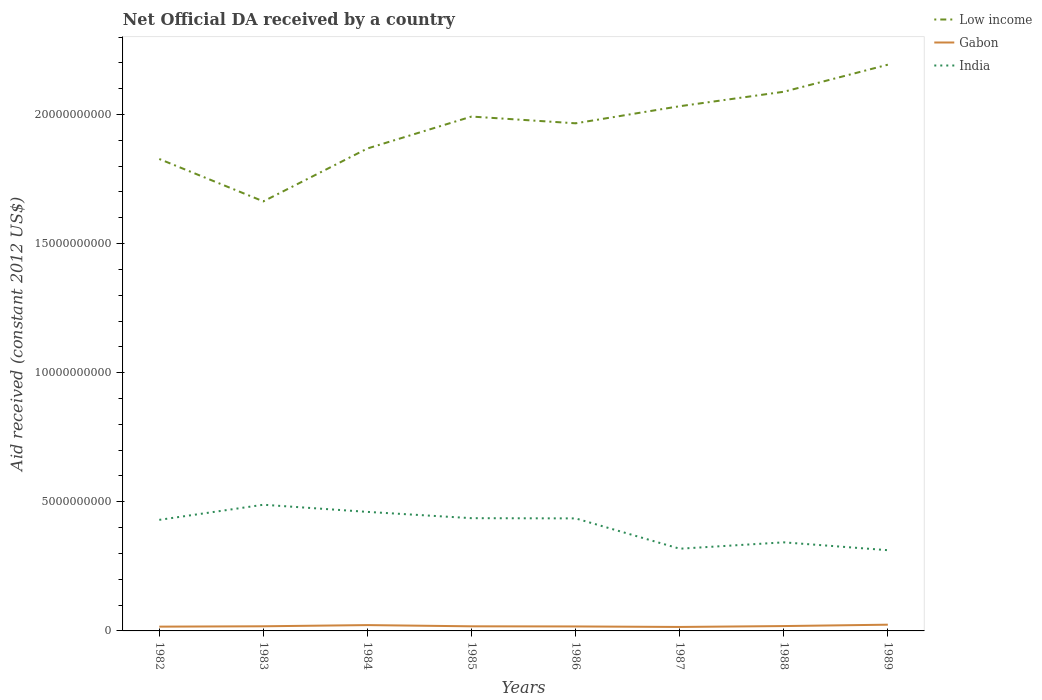How many different coloured lines are there?
Your answer should be compact. 3. Across all years, what is the maximum net official development assistance aid received in Low income?
Your response must be concise. 1.66e+1. In which year was the net official development assistance aid received in India maximum?
Offer a terse response. 1989. What is the total net official development assistance aid received in India in the graph?
Offer a very short reply. 1.18e+09. What is the difference between the highest and the second highest net official development assistance aid received in Gabon?
Ensure brevity in your answer.  8.77e+07. What is the difference between the highest and the lowest net official development assistance aid received in India?
Provide a short and direct response. 5. Does the graph contain any zero values?
Offer a terse response. No. How are the legend labels stacked?
Keep it short and to the point. Vertical. What is the title of the graph?
Offer a terse response. Net Official DA received by a country. What is the label or title of the X-axis?
Offer a terse response. Years. What is the label or title of the Y-axis?
Offer a terse response. Aid received (constant 2012 US$). What is the Aid received (constant 2012 US$) in Low income in 1982?
Offer a very short reply. 1.83e+1. What is the Aid received (constant 2012 US$) of Gabon in 1982?
Provide a succinct answer. 1.66e+08. What is the Aid received (constant 2012 US$) in India in 1982?
Ensure brevity in your answer.  4.30e+09. What is the Aid received (constant 2012 US$) of Low income in 1983?
Offer a very short reply. 1.66e+1. What is the Aid received (constant 2012 US$) in Gabon in 1983?
Your response must be concise. 1.80e+08. What is the Aid received (constant 2012 US$) of India in 1983?
Offer a very short reply. 4.89e+09. What is the Aid received (constant 2012 US$) of Low income in 1984?
Your answer should be compact. 1.87e+1. What is the Aid received (constant 2012 US$) in Gabon in 1984?
Your response must be concise. 2.26e+08. What is the Aid received (constant 2012 US$) of India in 1984?
Keep it short and to the point. 4.61e+09. What is the Aid received (constant 2012 US$) of Low income in 1985?
Your answer should be compact. 1.99e+1. What is the Aid received (constant 2012 US$) of Gabon in 1985?
Ensure brevity in your answer.  1.79e+08. What is the Aid received (constant 2012 US$) in India in 1985?
Your answer should be compact. 4.37e+09. What is the Aid received (constant 2012 US$) in Low income in 1986?
Give a very brief answer. 1.97e+1. What is the Aid received (constant 2012 US$) in Gabon in 1986?
Make the answer very short. 1.73e+08. What is the Aid received (constant 2012 US$) in India in 1986?
Give a very brief answer. 4.36e+09. What is the Aid received (constant 2012 US$) in Low income in 1987?
Provide a short and direct response. 2.03e+1. What is the Aid received (constant 2012 US$) of Gabon in 1987?
Offer a very short reply. 1.53e+08. What is the Aid received (constant 2012 US$) in India in 1987?
Keep it short and to the point. 3.18e+09. What is the Aid received (constant 2012 US$) in Low income in 1988?
Make the answer very short. 2.09e+1. What is the Aid received (constant 2012 US$) in Gabon in 1988?
Offer a terse response. 1.88e+08. What is the Aid received (constant 2012 US$) of India in 1988?
Provide a short and direct response. 3.43e+09. What is the Aid received (constant 2012 US$) of Low income in 1989?
Offer a terse response. 2.19e+1. What is the Aid received (constant 2012 US$) of Gabon in 1989?
Give a very brief answer. 2.41e+08. What is the Aid received (constant 2012 US$) of India in 1989?
Ensure brevity in your answer.  3.13e+09. Across all years, what is the maximum Aid received (constant 2012 US$) of Low income?
Your answer should be very brief. 2.19e+1. Across all years, what is the maximum Aid received (constant 2012 US$) in Gabon?
Provide a short and direct response. 2.41e+08. Across all years, what is the maximum Aid received (constant 2012 US$) in India?
Provide a succinct answer. 4.89e+09. Across all years, what is the minimum Aid received (constant 2012 US$) in Low income?
Your response must be concise. 1.66e+1. Across all years, what is the minimum Aid received (constant 2012 US$) of Gabon?
Offer a terse response. 1.53e+08. Across all years, what is the minimum Aid received (constant 2012 US$) of India?
Ensure brevity in your answer.  3.13e+09. What is the total Aid received (constant 2012 US$) in Low income in the graph?
Offer a terse response. 1.56e+11. What is the total Aid received (constant 2012 US$) of Gabon in the graph?
Ensure brevity in your answer.  1.51e+09. What is the total Aid received (constant 2012 US$) of India in the graph?
Your answer should be compact. 3.23e+1. What is the difference between the Aid received (constant 2012 US$) in Low income in 1982 and that in 1983?
Your response must be concise. 1.64e+09. What is the difference between the Aid received (constant 2012 US$) of Gabon in 1982 and that in 1983?
Your answer should be very brief. -1.36e+07. What is the difference between the Aid received (constant 2012 US$) of India in 1982 and that in 1983?
Provide a succinct answer. -5.85e+08. What is the difference between the Aid received (constant 2012 US$) in Low income in 1982 and that in 1984?
Offer a terse response. -4.07e+08. What is the difference between the Aid received (constant 2012 US$) of Gabon in 1982 and that in 1984?
Your answer should be compact. -5.96e+07. What is the difference between the Aid received (constant 2012 US$) of India in 1982 and that in 1984?
Make the answer very short. -3.08e+08. What is the difference between the Aid received (constant 2012 US$) of Low income in 1982 and that in 1985?
Provide a succinct answer. -1.64e+09. What is the difference between the Aid received (constant 2012 US$) of Gabon in 1982 and that in 1985?
Make the answer very short. -1.26e+07. What is the difference between the Aid received (constant 2012 US$) in India in 1982 and that in 1985?
Offer a very short reply. -6.47e+07. What is the difference between the Aid received (constant 2012 US$) of Low income in 1982 and that in 1986?
Ensure brevity in your answer.  -1.38e+09. What is the difference between the Aid received (constant 2012 US$) of Gabon in 1982 and that in 1986?
Give a very brief answer. -6.87e+06. What is the difference between the Aid received (constant 2012 US$) in India in 1982 and that in 1986?
Offer a terse response. -5.65e+07. What is the difference between the Aid received (constant 2012 US$) in Low income in 1982 and that in 1987?
Offer a terse response. -2.04e+09. What is the difference between the Aid received (constant 2012 US$) in Gabon in 1982 and that in 1987?
Ensure brevity in your answer.  1.25e+07. What is the difference between the Aid received (constant 2012 US$) of India in 1982 and that in 1987?
Make the answer very short. 1.12e+09. What is the difference between the Aid received (constant 2012 US$) in Low income in 1982 and that in 1988?
Ensure brevity in your answer.  -2.60e+09. What is the difference between the Aid received (constant 2012 US$) of Gabon in 1982 and that in 1988?
Give a very brief answer. -2.25e+07. What is the difference between the Aid received (constant 2012 US$) in India in 1982 and that in 1988?
Keep it short and to the point. 8.71e+08. What is the difference between the Aid received (constant 2012 US$) in Low income in 1982 and that in 1989?
Give a very brief answer. -3.65e+09. What is the difference between the Aid received (constant 2012 US$) of Gabon in 1982 and that in 1989?
Offer a terse response. -7.52e+07. What is the difference between the Aid received (constant 2012 US$) of India in 1982 and that in 1989?
Make the answer very short. 1.18e+09. What is the difference between the Aid received (constant 2012 US$) of Low income in 1983 and that in 1984?
Provide a succinct answer. -2.05e+09. What is the difference between the Aid received (constant 2012 US$) in Gabon in 1983 and that in 1984?
Keep it short and to the point. -4.60e+07. What is the difference between the Aid received (constant 2012 US$) of India in 1983 and that in 1984?
Keep it short and to the point. 2.77e+08. What is the difference between the Aid received (constant 2012 US$) of Low income in 1983 and that in 1985?
Ensure brevity in your answer.  -3.28e+09. What is the difference between the Aid received (constant 2012 US$) in Gabon in 1983 and that in 1985?
Your response must be concise. 1.05e+06. What is the difference between the Aid received (constant 2012 US$) of India in 1983 and that in 1985?
Provide a succinct answer. 5.20e+08. What is the difference between the Aid received (constant 2012 US$) of Low income in 1983 and that in 1986?
Offer a terse response. -3.02e+09. What is the difference between the Aid received (constant 2012 US$) of Gabon in 1983 and that in 1986?
Give a very brief answer. 6.77e+06. What is the difference between the Aid received (constant 2012 US$) of India in 1983 and that in 1986?
Provide a short and direct response. 5.29e+08. What is the difference between the Aid received (constant 2012 US$) in Low income in 1983 and that in 1987?
Your response must be concise. -3.69e+09. What is the difference between the Aid received (constant 2012 US$) of Gabon in 1983 and that in 1987?
Provide a short and direct response. 2.61e+07. What is the difference between the Aid received (constant 2012 US$) in India in 1983 and that in 1987?
Offer a terse response. 1.70e+09. What is the difference between the Aid received (constant 2012 US$) of Low income in 1983 and that in 1988?
Make the answer very short. -4.25e+09. What is the difference between the Aid received (constant 2012 US$) of Gabon in 1983 and that in 1988?
Your answer should be compact. -8.87e+06. What is the difference between the Aid received (constant 2012 US$) in India in 1983 and that in 1988?
Give a very brief answer. 1.46e+09. What is the difference between the Aid received (constant 2012 US$) of Low income in 1983 and that in 1989?
Provide a short and direct response. -5.29e+09. What is the difference between the Aid received (constant 2012 US$) in Gabon in 1983 and that in 1989?
Give a very brief answer. -6.16e+07. What is the difference between the Aid received (constant 2012 US$) of India in 1983 and that in 1989?
Your answer should be very brief. 1.76e+09. What is the difference between the Aid received (constant 2012 US$) of Low income in 1984 and that in 1985?
Your response must be concise. -1.24e+09. What is the difference between the Aid received (constant 2012 US$) in Gabon in 1984 and that in 1985?
Your response must be concise. 4.70e+07. What is the difference between the Aid received (constant 2012 US$) of India in 1984 and that in 1985?
Your answer should be very brief. 2.44e+08. What is the difference between the Aid received (constant 2012 US$) in Low income in 1984 and that in 1986?
Offer a terse response. -9.75e+08. What is the difference between the Aid received (constant 2012 US$) of Gabon in 1984 and that in 1986?
Provide a short and direct response. 5.27e+07. What is the difference between the Aid received (constant 2012 US$) of India in 1984 and that in 1986?
Keep it short and to the point. 2.52e+08. What is the difference between the Aid received (constant 2012 US$) of Low income in 1984 and that in 1987?
Your response must be concise. -1.64e+09. What is the difference between the Aid received (constant 2012 US$) in Gabon in 1984 and that in 1987?
Your answer should be compact. 7.21e+07. What is the difference between the Aid received (constant 2012 US$) in India in 1984 and that in 1987?
Provide a short and direct response. 1.43e+09. What is the difference between the Aid received (constant 2012 US$) of Low income in 1984 and that in 1988?
Provide a short and direct response. -2.20e+09. What is the difference between the Aid received (constant 2012 US$) in Gabon in 1984 and that in 1988?
Your answer should be very brief. 3.71e+07. What is the difference between the Aid received (constant 2012 US$) in India in 1984 and that in 1988?
Keep it short and to the point. 1.18e+09. What is the difference between the Aid received (constant 2012 US$) of Low income in 1984 and that in 1989?
Ensure brevity in your answer.  -3.25e+09. What is the difference between the Aid received (constant 2012 US$) of Gabon in 1984 and that in 1989?
Offer a terse response. -1.56e+07. What is the difference between the Aid received (constant 2012 US$) in India in 1984 and that in 1989?
Provide a succinct answer. 1.48e+09. What is the difference between the Aid received (constant 2012 US$) of Low income in 1985 and that in 1986?
Offer a terse response. 2.61e+08. What is the difference between the Aid received (constant 2012 US$) in Gabon in 1985 and that in 1986?
Keep it short and to the point. 5.72e+06. What is the difference between the Aid received (constant 2012 US$) in India in 1985 and that in 1986?
Ensure brevity in your answer.  8.18e+06. What is the difference between the Aid received (constant 2012 US$) of Low income in 1985 and that in 1987?
Provide a short and direct response. -4.01e+08. What is the difference between the Aid received (constant 2012 US$) of Gabon in 1985 and that in 1987?
Give a very brief answer. 2.51e+07. What is the difference between the Aid received (constant 2012 US$) of India in 1985 and that in 1987?
Provide a short and direct response. 1.18e+09. What is the difference between the Aid received (constant 2012 US$) in Low income in 1985 and that in 1988?
Your response must be concise. -9.61e+08. What is the difference between the Aid received (constant 2012 US$) in Gabon in 1985 and that in 1988?
Your answer should be very brief. -9.92e+06. What is the difference between the Aid received (constant 2012 US$) of India in 1985 and that in 1988?
Your answer should be compact. 9.36e+08. What is the difference between the Aid received (constant 2012 US$) in Low income in 1985 and that in 1989?
Give a very brief answer. -2.01e+09. What is the difference between the Aid received (constant 2012 US$) in Gabon in 1985 and that in 1989?
Your answer should be compact. -6.26e+07. What is the difference between the Aid received (constant 2012 US$) in India in 1985 and that in 1989?
Provide a short and direct response. 1.24e+09. What is the difference between the Aid received (constant 2012 US$) in Low income in 1986 and that in 1987?
Your response must be concise. -6.62e+08. What is the difference between the Aid received (constant 2012 US$) of Gabon in 1986 and that in 1987?
Offer a very short reply. 1.93e+07. What is the difference between the Aid received (constant 2012 US$) of India in 1986 and that in 1987?
Your answer should be very brief. 1.17e+09. What is the difference between the Aid received (constant 2012 US$) in Low income in 1986 and that in 1988?
Make the answer very short. -1.22e+09. What is the difference between the Aid received (constant 2012 US$) in Gabon in 1986 and that in 1988?
Make the answer very short. -1.56e+07. What is the difference between the Aid received (constant 2012 US$) of India in 1986 and that in 1988?
Keep it short and to the point. 9.27e+08. What is the difference between the Aid received (constant 2012 US$) of Low income in 1986 and that in 1989?
Make the answer very short. -2.27e+09. What is the difference between the Aid received (constant 2012 US$) in Gabon in 1986 and that in 1989?
Your answer should be very brief. -6.83e+07. What is the difference between the Aid received (constant 2012 US$) in India in 1986 and that in 1989?
Make the answer very short. 1.23e+09. What is the difference between the Aid received (constant 2012 US$) in Low income in 1987 and that in 1988?
Keep it short and to the point. -5.61e+08. What is the difference between the Aid received (constant 2012 US$) in Gabon in 1987 and that in 1988?
Keep it short and to the point. -3.50e+07. What is the difference between the Aid received (constant 2012 US$) in India in 1987 and that in 1988?
Ensure brevity in your answer.  -2.47e+08. What is the difference between the Aid received (constant 2012 US$) of Low income in 1987 and that in 1989?
Your response must be concise. -1.61e+09. What is the difference between the Aid received (constant 2012 US$) of Gabon in 1987 and that in 1989?
Your answer should be compact. -8.77e+07. What is the difference between the Aid received (constant 2012 US$) in India in 1987 and that in 1989?
Offer a terse response. 5.72e+07. What is the difference between the Aid received (constant 2012 US$) of Low income in 1988 and that in 1989?
Your response must be concise. -1.05e+09. What is the difference between the Aid received (constant 2012 US$) of Gabon in 1988 and that in 1989?
Give a very brief answer. -5.27e+07. What is the difference between the Aid received (constant 2012 US$) of India in 1988 and that in 1989?
Keep it short and to the point. 3.04e+08. What is the difference between the Aid received (constant 2012 US$) in Low income in 1982 and the Aid received (constant 2012 US$) in Gabon in 1983?
Ensure brevity in your answer.  1.81e+1. What is the difference between the Aid received (constant 2012 US$) in Low income in 1982 and the Aid received (constant 2012 US$) in India in 1983?
Provide a short and direct response. 1.34e+1. What is the difference between the Aid received (constant 2012 US$) in Gabon in 1982 and the Aid received (constant 2012 US$) in India in 1983?
Give a very brief answer. -4.72e+09. What is the difference between the Aid received (constant 2012 US$) in Low income in 1982 and the Aid received (constant 2012 US$) in Gabon in 1984?
Offer a very short reply. 1.81e+1. What is the difference between the Aid received (constant 2012 US$) in Low income in 1982 and the Aid received (constant 2012 US$) in India in 1984?
Your response must be concise. 1.37e+1. What is the difference between the Aid received (constant 2012 US$) in Gabon in 1982 and the Aid received (constant 2012 US$) in India in 1984?
Your answer should be compact. -4.44e+09. What is the difference between the Aid received (constant 2012 US$) in Low income in 1982 and the Aid received (constant 2012 US$) in Gabon in 1985?
Make the answer very short. 1.81e+1. What is the difference between the Aid received (constant 2012 US$) in Low income in 1982 and the Aid received (constant 2012 US$) in India in 1985?
Make the answer very short. 1.39e+1. What is the difference between the Aid received (constant 2012 US$) in Gabon in 1982 and the Aid received (constant 2012 US$) in India in 1985?
Keep it short and to the point. -4.20e+09. What is the difference between the Aid received (constant 2012 US$) of Low income in 1982 and the Aid received (constant 2012 US$) of Gabon in 1986?
Ensure brevity in your answer.  1.81e+1. What is the difference between the Aid received (constant 2012 US$) of Low income in 1982 and the Aid received (constant 2012 US$) of India in 1986?
Your response must be concise. 1.39e+1. What is the difference between the Aid received (constant 2012 US$) of Gabon in 1982 and the Aid received (constant 2012 US$) of India in 1986?
Your answer should be compact. -4.19e+09. What is the difference between the Aid received (constant 2012 US$) of Low income in 1982 and the Aid received (constant 2012 US$) of Gabon in 1987?
Make the answer very short. 1.81e+1. What is the difference between the Aid received (constant 2012 US$) in Low income in 1982 and the Aid received (constant 2012 US$) in India in 1987?
Keep it short and to the point. 1.51e+1. What is the difference between the Aid received (constant 2012 US$) of Gabon in 1982 and the Aid received (constant 2012 US$) of India in 1987?
Your answer should be very brief. -3.02e+09. What is the difference between the Aid received (constant 2012 US$) of Low income in 1982 and the Aid received (constant 2012 US$) of Gabon in 1988?
Make the answer very short. 1.81e+1. What is the difference between the Aid received (constant 2012 US$) in Low income in 1982 and the Aid received (constant 2012 US$) in India in 1988?
Your response must be concise. 1.48e+1. What is the difference between the Aid received (constant 2012 US$) of Gabon in 1982 and the Aid received (constant 2012 US$) of India in 1988?
Your answer should be compact. -3.26e+09. What is the difference between the Aid received (constant 2012 US$) in Low income in 1982 and the Aid received (constant 2012 US$) in Gabon in 1989?
Offer a very short reply. 1.80e+1. What is the difference between the Aid received (constant 2012 US$) in Low income in 1982 and the Aid received (constant 2012 US$) in India in 1989?
Ensure brevity in your answer.  1.52e+1. What is the difference between the Aid received (constant 2012 US$) of Gabon in 1982 and the Aid received (constant 2012 US$) of India in 1989?
Give a very brief answer. -2.96e+09. What is the difference between the Aid received (constant 2012 US$) in Low income in 1983 and the Aid received (constant 2012 US$) in Gabon in 1984?
Your answer should be compact. 1.64e+1. What is the difference between the Aid received (constant 2012 US$) of Low income in 1983 and the Aid received (constant 2012 US$) of India in 1984?
Keep it short and to the point. 1.20e+1. What is the difference between the Aid received (constant 2012 US$) in Gabon in 1983 and the Aid received (constant 2012 US$) in India in 1984?
Ensure brevity in your answer.  -4.43e+09. What is the difference between the Aid received (constant 2012 US$) in Low income in 1983 and the Aid received (constant 2012 US$) in Gabon in 1985?
Keep it short and to the point. 1.65e+1. What is the difference between the Aid received (constant 2012 US$) of Low income in 1983 and the Aid received (constant 2012 US$) of India in 1985?
Give a very brief answer. 1.23e+1. What is the difference between the Aid received (constant 2012 US$) of Gabon in 1983 and the Aid received (constant 2012 US$) of India in 1985?
Provide a succinct answer. -4.19e+09. What is the difference between the Aid received (constant 2012 US$) in Low income in 1983 and the Aid received (constant 2012 US$) in Gabon in 1986?
Provide a succinct answer. 1.65e+1. What is the difference between the Aid received (constant 2012 US$) of Low income in 1983 and the Aid received (constant 2012 US$) of India in 1986?
Make the answer very short. 1.23e+1. What is the difference between the Aid received (constant 2012 US$) of Gabon in 1983 and the Aid received (constant 2012 US$) of India in 1986?
Provide a short and direct response. -4.18e+09. What is the difference between the Aid received (constant 2012 US$) of Low income in 1983 and the Aid received (constant 2012 US$) of Gabon in 1987?
Your answer should be very brief. 1.65e+1. What is the difference between the Aid received (constant 2012 US$) of Low income in 1983 and the Aid received (constant 2012 US$) of India in 1987?
Provide a short and direct response. 1.35e+1. What is the difference between the Aid received (constant 2012 US$) of Gabon in 1983 and the Aid received (constant 2012 US$) of India in 1987?
Make the answer very short. -3.00e+09. What is the difference between the Aid received (constant 2012 US$) in Low income in 1983 and the Aid received (constant 2012 US$) in Gabon in 1988?
Your answer should be very brief. 1.64e+1. What is the difference between the Aid received (constant 2012 US$) of Low income in 1983 and the Aid received (constant 2012 US$) of India in 1988?
Your answer should be compact. 1.32e+1. What is the difference between the Aid received (constant 2012 US$) in Gabon in 1983 and the Aid received (constant 2012 US$) in India in 1988?
Provide a short and direct response. -3.25e+09. What is the difference between the Aid received (constant 2012 US$) of Low income in 1983 and the Aid received (constant 2012 US$) of Gabon in 1989?
Your answer should be very brief. 1.64e+1. What is the difference between the Aid received (constant 2012 US$) of Low income in 1983 and the Aid received (constant 2012 US$) of India in 1989?
Your answer should be very brief. 1.35e+1. What is the difference between the Aid received (constant 2012 US$) of Gabon in 1983 and the Aid received (constant 2012 US$) of India in 1989?
Offer a very short reply. -2.95e+09. What is the difference between the Aid received (constant 2012 US$) in Low income in 1984 and the Aid received (constant 2012 US$) in Gabon in 1985?
Offer a terse response. 1.85e+1. What is the difference between the Aid received (constant 2012 US$) of Low income in 1984 and the Aid received (constant 2012 US$) of India in 1985?
Your response must be concise. 1.43e+1. What is the difference between the Aid received (constant 2012 US$) in Gabon in 1984 and the Aid received (constant 2012 US$) in India in 1985?
Give a very brief answer. -4.14e+09. What is the difference between the Aid received (constant 2012 US$) of Low income in 1984 and the Aid received (constant 2012 US$) of Gabon in 1986?
Your answer should be compact. 1.85e+1. What is the difference between the Aid received (constant 2012 US$) of Low income in 1984 and the Aid received (constant 2012 US$) of India in 1986?
Make the answer very short. 1.43e+1. What is the difference between the Aid received (constant 2012 US$) of Gabon in 1984 and the Aid received (constant 2012 US$) of India in 1986?
Offer a very short reply. -4.13e+09. What is the difference between the Aid received (constant 2012 US$) of Low income in 1984 and the Aid received (constant 2012 US$) of Gabon in 1987?
Make the answer very short. 1.85e+1. What is the difference between the Aid received (constant 2012 US$) in Low income in 1984 and the Aid received (constant 2012 US$) in India in 1987?
Keep it short and to the point. 1.55e+1. What is the difference between the Aid received (constant 2012 US$) of Gabon in 1984 and the Aid received (constant 2012 US$) of India in 1987?
Offer a very short reply. -2.96e+09. What is the difference between the Aid received (constant 2012 US$) of Low income in 1984 and the Aid received (constant 2012 US$) of Gabon in 1988?
Your answer should be very brief. 1.85e+1. What is the difference between the Aid received (constant 2012 US$) of Low income in 1984 and the Aid received (constant 2012 US$) of India in 1988?
Your response must be concise. 1.53e+1. What is the difference between the Aid received (constant 2012 US$) in Gabon in 1984 and the Aid received (constant 2012 US$) in India in 1988?
Offer a terse response. -3.21e+09. What is the difference between the Aid received (constant 2012 US$) of Low income in 1984 and the Aid received (constant 2012 US$) of Gabon in 1989?
Ensure brevity in your answer.  1.84e+1. What is the difference between the Aid received (constant 2012 US$) in Low income in 1984 and the Aid received (constant 2012 US$) in India in 1989?
Give a very brief answer. 1.56e+1. What is the difference between the Aid received (constant 2012 US$) in Gabon in 1984 and the Aid received (constant 2012 US$) in India in 1989?
Keep it short and to the point. -2.90e+09. What is the difference between the Aid received (constant 2012 US$) in Low income in 1985 and the Aid received (constant 2012 US$) in Gabon in 1986?
Provide a short and direct response. 1.97e+1. What is the difference between the Aid received (constant 2012 US$) in Low income in 1985 and the Aid received (constant 2012 US$) in India in 1986?
Keep it short and to the point. 1.56e+1. What is the difference between the Aid received (constant 2012 US$) of Gabon in 1985 and the Aid received (constant 2012 US$) of India in 1986?
Offer a terse response. -4.18e+09. What is the difference between the Aid received (constant 2012 US$) of Low income in 1985 and the Aid received (constant 2012 US$) of Gabon in 1987?
Provide a succinct answer. 1.98e+1. What is the difference between the Aid received (constant 2012 US$) of Low income in 1985 and the Aid received (constant 2012 US$) of India in 1987?
Your response must be concise. 1.67e+1. What is the difference between the Aid received (constant 2012 US$) in Gabon in 1985 and the Aid received (constant 2012 US$) in India in 1987?
Your response must be concise. -3.01e+09. What is the difference between the Aid received (constant 2012 US$) of Low income in 1985 and the Aid received (constant 2012 US$) of Gabon in 1988?
Provide a short and direct response. 1.97e+1. What is the difference between the Aid received (constant 2012 US$) of Low income in 1985 and the Aid received (constant 2012 US$) of India in 1988?
Ensure brevity in your answer.  1.65e+1. What is the difference between the Aid received (constant 2012 US$) in Gabon in 1985 and the Aid received (constant 2012 US$) in India in 1988?
Your answer should be compact. -3.25e+09. What is the difference between the Aid received (constant 2012 US$) of Low income in 1985 and the Aid received (constant 2012 US$) of Gabon in 1989?
Provide a succinct answer. 1.97e+1. What is the difference between the Aid received (constant 2012 US$) of Low income in 1985 and the Aid received (constant 2012 US$) of India in 1989?
Your response must be concise. 1.68e+1. What is the difference between the Aid received (constant 2012 US$) of Gabon in 1985 and the Aid received (constant 2012 US$) of India in 1989?
Ensure brevity in your answer.  -2.95e+09. What is the difference between the Aid received (constant 2012 US$) of Low income in 1986 and the Aid received (constant 2012 US$) of Gabon in 1987?
Offer a terse response. 1.95e+1. What is the difference between the Aid received (constant 2012 US$) of Low income in 1986 and the Aid received (constant 2012 US$) of India in 1987?
Provide a succinct answer. 1.65e+1. What is the difference between the Aid received (constant 2012 US$) in Gabon in 1986 and the Aid received (constant 2012 US$) in India in 1987?
Give a very brief answer. -3.01e+09. What is the difference between the Aid received (constant 2012 US$) in Low income in 1986 and the Aid received (constant 2012 US$) in Gabon in 1988?
Give a very brief answer. 1.95e+1. What is the difference between the Aid received (constant 2012 US$) in Low income in 1986 and the Aid received (constant 2012 US$) in India in 1988?
Your answer should be compact. 1.62e+1. What is the difference between the Aid received (constant 2012 US$) of Gabon in 1986 and the Aid received (constant 2012 US$) of India in 1988?
Your response must be concise. -3.26e+09. What is the difference between the Aid received (constant 2012 US$) of Low income in 1986 and the Aid received (constant 2012 US$) of Gabon in 1989?
Offer a very short reply. 1.94e+1. What is the difference between the Aid received (constant 2012 US$) of Low income in 1986 and the Aid received (constant 2012 US$) of India in 1989?
Your answer should be compact. 1.65e+1. What is the difference between the Aid received (constant 2012 US$) of Gabon in 1986 and the Aid received (constant 2012 US$) of India in 1989?
Make the answer very short. -2.95e+09. What is the difference between the Aid received (constant 2012 US$) in Low income in 1987 and the Aid received (constant 2012 US$) in Gabon in 1988?
Offer a very short reply. 2.01e+1. What is the difference between the Aid received (constant 2012 US$) in Low income in 1987 and the Aid received (constant 2012 US$) in India in 1988?
Ensure brevity in your answer.  1.69e+1. What is the difference between the Aid received (constant 2012 US$) of Gabon in 1987 and the Aid received (constant 2012 US$) of India in 1988?
Provide a succinct answer. -3.28e+09. What is the difference between the Aid received (constant 2012 US$) of Low income in 1987 and the Aid received (constant 2012 US$) of Gabon in 1989?
Your answer should be compact. 2.01e+1. What is the difference between the Aid received (constant 2012 US$) of Low income in 1987 and the Aid received (constant 2012 US$) of India in 1989?
Your answer should be very brief. 1.72e+1. What is the difference between the Aid received (constant 2012 US$) of Gabon in 1987 and the Aid received (constant 2012 US$) of India in 1989?
Provide a succinct answer. -2.97e+09. What is the difference between the Aid received (constant 2012 US$) of Low income in 1988 and the Aid received (constant 2012 US$) of Gabon in 1989?
Give a very brief answer. 2.06e+1. What is the difference between the Aid received (constant 2012 US$) of Low income in 1988 and the Aid received (constant 2012 US$) of India in 1989?
Offer a very short reply. 1.78e+1. What is the difference between the Aid received (constant 2012 US$) of Gabon in 1988 and the Aid received (constant 2012 US$) of India in 1989?
Your response must be concise. -2.94e+09. What is the average Aid received (constant 2012 US$) of Low income per year?
Give a very brief answer. 1.95e+1. What is the average Aid received (constant 2012 US$) in Gabon per year?
Keep it short and to the point. 1.88e+08. What is the average Aid received (constant 2012 US$) of India per year?
Offer a very short reply. 4.03e+09. In the year 1982, what is the difference between the Aid received (constant 2012 US$) of Low income and Aid received (constant 2012 US$) of Gabon?
Offer a very short reply. 1.81e+1. In the year 1982, what is the difference between the Aid received (constant 2012 US$) of Low income and Aid received (constant 2012 US$) of India?
Make the answer very short. 1.40e+1. In the year 1982, what is the difference between the Aid received (constant 2012 US$) of Gabon and Aid received (constant 2012 US$) of India?
Give a very brief answer. -4.14e+09. In the year 1983, what is the difference between the Aid received (constant 2012 US$) in Low income and Aid received (constant 2012 US$) in Gabon?
Ensure brevity in your answer.  1.65e+1. In the year 1983, what is the difference between the Aid received (constant 2012 US$) in Low income and Aid received (constant 2012 US$) in India?
Your answer should be very brief. 1.17e+1. In the year 1983, what is the difference between the Aid received (constant 2012 US$) of Gabon and Aid received (constant 2012 US$) of India?
Your answer should be very brief. -4.71e+09. In the year 1984, what is the difference between the Aid received (constant 2012 US$) of Low income and Aid received (constant 2012 US$) of Gabon?
Provide a succinct answer. 1.85e+1. In the year 1984, what is the difference between the Aid received (constant 2012 US$) of Low income and Aid received (constant 2012 US$) of India?
Offer a very short reply. 1.41e+1. In the year 1984, what is the difference between the Aid received (constant 2012 US$) in Gabon and Aid received (constant 2012 US$) in India?
Provide a short and direct response. -4.38e+09. In the year 1985, what is the difference between the Aid received (constant 2012 US$) of Low income and Aid received (constant 2012 US$) of Gabon?
Provide a succinct answer. 1.97e+1. In the year 1985, what is the difference between the Aid received (constant 2012 US$) of Low income and Aid received (constant 2012 US$) of India?
Your answer should be very brief. 1.56e+1. In the year 1985, what is the difference between the Aid received (constant 2012 US$) in Gabon and Aid received (constant 2012 US$) in India?
Offer a terse response. -4.19e+09. In the year 1986, what is the difference between the Aid received (constant 2012 US$) of Low income and Aid received (constant 2012 US$) of Gabon?
Your answer should be very brief. 1.95e+1. In the year 1986, what is the difference between the Aid received (constant 2012 US$) in Low income and Aid received (constant 2012 US$) in India?
Provide a short and direct response. 1.53e+1. In the year 1986, what is the difference between the Aid received (constant 2012 US$) in Gabon and Aid received (constant 2012 US$) in India?
Your response must be concise. -4.19e+09. In the year 1987, what is the difference between the Aid received (constant 2012 US$) in Low income and Aid received (constant 2012 US$) in Gabon?
Provide a short and direct response. 2.02e+1. In the year 1987, what is the difference between the Aid received (constant 2012 US$) in Low income and Aid received (constant 2012 US$) in India?
Provide a short and direct response. 1.71e+1. In the year 1987, what is the difference between the Aid received (constant 2012 US$) in Gabon and Aid received (constant 2012 US$) in India?
Your response must be concise. -3.03e+09. In the year 1988, what is the difference between the Aid received (constant 2012 US$) in Low income and Aid received (constant 2012 US$) in Gabon?
Your response must be concise. 2.07e+1. In the year 1988, what is the difference between the Aid received (constant 2012 US$) in Low income and Aid received (constant 2012 US$) in India?
Give a very brief answer. 1.75e+1. In the year 1988, what is the difference between the Aid received (constant 2012 US$) in Gabon and Aid received (constant 2012 US$) in India?
Provide a short and direct response. -3.24e+09. In the year 1989, what is the difference between the Aid received (constant 2012 US$) in Low income and Aid received (constant 2012 US$) in Gabon?
Make the answer very short. 2.17e+1. In the year 1989, what is the difference between the Aid received (constant 2012 US$) of Low income and Aid received (constant 2012 US$) of India?
Ensure brevity in your answer.  1.88e+1. In the year 1989, what is the difference between the Aid received (constant 2012 US$) of Gabon and Aid received (constant 2012 US$) of India?
Ensure brevity in your answer.  -2.89e+09. What is the ratio of the Aid received (constant 2012 US$) of Low income in 1982 to that in 1983?
Keep it short and to the point. 1.1. What is the ratio of the Aid received (constant 2012 US$) in Gabon in 1982 to that in 1983?
Keep it short and to the point. 0.92. What is the ratio of the Aid received (constant 2012 US$) in India in 1982 to that in 1983?
Your answer should be very brief. 0.88. What is the ratio of the Aid received (constant 2012 US$) of Low income in 1982 to that in 1984?
Provide a short and direct response. 0.98. What is the ratio of the Aid received (constant 2012 US$) of Gabon in 1982 to that in 1984?
Your answer should be very brief. 0.74. What is the ratio of the Aid received (constant 2012 US$) in India in 1982 to that in 1984?
Give a very brief answer. 0.93. What is the ratio of the Aid received (constant 2012 US$) in Low income in 1982 to that in 1985?
Keep it short and to the point. 0.92. What is the ratio of the Aid received (constant 2012 US$) of Gabon in 1982 to that in 1985?
Offer a very short reply. 0.93. What is the ratio of the Aid received (constant 2012 US$) in India in 1982 to that in 1985?
Provide a short and direct response. 0.99. What is the ratio of the Aid received (constant 2012 US$) of Low income in 1982 to that in 1986?
Give a very brief answer. 0.93. What is the ratio of the Aid received (constant 2012 US$) of Gabon in 1982 to that in 1986?
Give a very brief answer. 0.96. What is the ratio of the Aid received (constant 2012 US$) of India in 1982 to that in 1986?
Keep it short and to the point. 0.99. What is the ratio of the Aid received (constant 2012 US$) of Low income in 1982 to that in 1987?
Offer a terse response. 0.9. What is the ratio of the Aid received (constant 2012 US$) of Gabon in 1982 to that in 1987?
Make the answer very short. 1.08. What is the ratio of the Aid received (constant 2012 US$) in India in 1982 to that in 1987?
Your answer should be compact. 1.35. What is the ratio of the Aid received (constant 2012 US$) of Low income in 1982 to that in 1988?
Offer a very short reply. 0.88. What is the ratio of the Aid received (constant 2012 US$) of Gabon in 1982 to that in 1988?
Your answer should be compact. 0.88. What is the ratio of the Aid received (constant 2012 US$) in India in 1982 to that in 1988?
Provide a succinct answer. 1.25. What is the ratio of the Aid received (constant 2012 US$) in Low income in 1982 to that in 1989?
Ensure brevity in your answer.  0.83. What is the ratio of the Aid received (constant 2012 US$) in Gabon in 1982 to that in 1989?
Offer a terse response. 0.69. What is the ratio of the Aid received (constant 2012 US$) in India in 1982 to that in 1989?
Your answer should be very brief. 1.38. What is the ratio of the Aid received (constant 2012 US$) of Low income in 1983 to that in 1984?
Your answer should be very brief. 0.89. What is the ratio of the Aid received (constant 2012 US$) of Gabon in 1983 to that in 1984?
Give a very brief answer. 0.8. What is the ratio of the Aid received (constant 2012 US$) in India in 1983 to that in 1984?
Provide a succinct answer. 1.06. What is the ratio of the Aid received (constant 2012 US$) of Low income in 1983 to that in 1985?
Ensure brevity in your answer.  0.84. What is the ratio of the Aid received (constant 2012 US$) of Gabon in 1983 to that in 1985?
Keep it short and to the point. 1.01. What is the ratio of the Aid received (constant 2012 US$) in India in 1983 to that in 1985?
Your response must be concise. 1.12. What is the ratio of the Aid received (constant 2012 US$) of Low income in 1983 to that in 1986?
Your response must be concise. 0.85. What is the ratio of the Aid received (constant 2012 US$) of Gabon in 1983 to that in 1986?
Your answer should be very brief. 1.04. What is the ratio of the Aid received (constant 2012 US$) of India in 1983 to that in 1986?
Offer a very short reply. 1.12. What is the ratio of the Aid received (constant 2012 US$) in Low income in 1983 to that in 1987?
Make the answer very short. 0.82. What is the ratio of the Aid received (constant 2012 US$) in Gabon in 1983 to that in 1987?
Make the answer very short. 1.17. What is the ratio of the Aid received (constant 2012 US$) in India in 1983 to that in 1987?
Offer a terse response. 1.53. What is the ratio of the Aid received (constant 2012 US$) of Low income in 1983 to that in 1988?
Ensure brevity in your answer.  0.8. What is the ratio of the Aid received (constant 2012 US$) in Gabon in 1983 to that in 1988?
Offer a terse response. 0.95. What is the ratio of the Aid received (constant 2012 US$) in India in 1983 to that in 1988?
Offer a very short reply. 1.42. What is the ratio of the Aid received (constant 2012 US$) of Low income in 1983 to that in 1989?
Your response must be concise. 0.76. What is the ratio of the Aid received (constant 2012 US$) of Gabon in 1983 to that in 1989?
Give a very brief answer. 0.74. What is the ratio of the Aid received (constant 2012 US$) in India in 1983 to that in 1989?
Keep it short and to the point. 1.56. What is the ratio of the Aid received (constant 2012 US$) in Low income in 1984 to that in 1985?
Keep it short and to the point. 0.94. What is the ratio of the Aid received (constant 2012 US$) of Gabon in 1984 to that in 1985?
Make the answer very short. 1.26. What is the ratio of the Aid received (constant 2012 US$) in India in 1984 to that in 1985?
Ensure brevity in your answer.  1.06. What is the ratio of the Aid received (constant 2012 US$) of Low income in 1984 to that in 1986?
Make the answer very short. 0.95. What is the ratio of the Aid received (constant 2012 US$) of Gabon in 1984 to that in 1986?
Your response must be concise. 1.31. What is the ratio of the Aid received (constant 2012 US$) of India in 1984 to that in 1986?
Provide a short and direct response. 1.06. What is the ratio of the Aid received (constant 2012 US$) in Low income in 1984 to that in 1987?
Provide a short and direct response. 0.92. What is the ratio of the Aid received (constant 2012 US$) in Gabon in 1984 to that in 1987?
Give a very brief answer. 1.47. What is the ratio of the Aid received (constant 2012 US$) in India in 1984 to that in 1987?
Your response must be concise. 1.45. What is the ratio of the Aid received (constant 2012 US$) of Low income in 1984 to that in 1988?
Your response must be concise. 0.89. What is the ratio of the Aid received (constant 2012 US$) of Gabon in 1984 to that in 1988?
Your response must be concise. 1.2. What is the ratio of the Aid received (constant 2012 US$) in India in 1984 to that in 1988?
Provide a short and direct response. 1.34. What is the ratio of the Aid received (constant 2012 US$) in Low income in 1984 to that in 1989?
Offer a terse response. 0.85. What is the ratio of the Aid received (constant 2012 US$) of Gabon in 1984 to that in 1989?
Offer a terse response. 0.94. What is the ratio of the Aid received (constant 2012 US$) of India in 1984 to that in 1989?
Your answer should be very brief. 1.47. What is the ratio of the Aid received (constant 2012 US$) in Low income in 1985 to that in 1986?
Your response must be concise. 1.01. What is the ratio of the Aid received (constant 2012 US$) in Gabon in 1985 to that in 1986?
Keep it short and to the point. 1.03. What is the ratio of the Aid received (constant 2012 US$) in India in 1985 to that in 1986?
Your answer should be compact. 1. What is the ratio of the Aid received (constant 2012 US$) of Low income in 1985 to that in 1987?
Keep it short and to the point. 0.98. What is the ratio of the Aid received (constant 2012 US$) in Gabon in 1985 to that in 1987?
Keep it short and to the point. 1.16. What is the ratio of the Aid received (constant 2012 US$) of India in 1985 to that in 1987?
Offer a terse response. 1.37. What is the ratio of the Aid received (constant 2012 US$) of Low income in 1985 to that in 1988?
Keep it short and to the point. 0.95. What is the ratio of the Aid received (constant 2012 US$) in India in 1985 to that in 1988?
Offer a very short reply. 1.27. What is the ratio of the Aid received (constant 2012 US$) of Low income in 1985 to that in 1989?
Ensure brevity in your answer.  0.91. What is the ratio of the Aid received (constant 2012 US$) in Gabon in 1985 to that in 1989?
Keep it short and to the point. 0.74. What is the ratio of the Aid received (constant 2012 US$) of India in 1985 to that in 1989?
Your answer should be compact. 1.4. What is the ratio of the Aid received (constant 2012 US$) in Low income in 1986 to that in 1987?
Your response must be concise. 0.97. What is the ratio of the Aid received (constant 2012 US$) of Gabon in 1986 to that in 1987?
Your answer should be very brief. 1.13. What is the ratio of the Aid received (constant 2012 US$) of India in 1986 to that in 1987?
Provide a succinct answer. 1.37. What is the ratio of the Aid received (constant 2012 US$) of Low income in 1986 to that in 1988?
Your answer should be compact. 0.94. What is the ratio of the Aid received (constant 2012 US$) in Gabon in 1986 to that in 1988?
Make the answer very short. 0.92. What is the ratio of the Aid received (constant 2012 US$) of India in 1986 to that in 1988?
Keep it short and to the point. 1.27. What is the ratio of the Aid received (constant 2012 US$) of Low income in 1986 to that in 1989?
Give a very brief answer. 0.9. What is the ratio of the Aid received (constant 2012 US$) in Gabon in 1986 to that in 1989?
Give a very brief answer. 0.72. What is the ratio of the Aid received (constant 2012 US$) of India in 1986 to that in 1989?
Your answer should be compact. 1.39. What is the ratio of the Aid received (constant 2012 US$) of Low income in 1987 to that in 1988?
Your answer should be compact. 0.97. What is the ratio of the Aid received (constant 2012 US$) in Gabon in 1987 to that in 1988?
Give a very brief answer. 0.81. What is the ratio of the Aid received (constant 2012 US$) in India in 1987 to that in 1988?
Your answer should be very brief. 0.93. What is the ratio of the Aid received (constant 2012 US$) in Low income in 1987 to that in 1989?
Ensure brevity in your answer.  0.93. What is the ratio of the Aid received (constant 2012 US$) in Gabon in 1987 to that in 1989?
Your answer should be compact. 0.64. What is the ratio of the Aid received (constant 2012 US$) in India in 1987 to that in 1989?
Your answer should be very brief. 1.02. What is the ratio of the Aid received (constant 2012 US$) of Low income in 1988 to that in 1989?
Offer a very short reply. 0.95. What is the ratio of the Aid received (constant 2012 US$) of Gabon in 1988 to that in 1989?
Provide a short and direct response. 0.78. What is the ratio of the Aid received (constant 2012 US$) in India in 1988 to that in 1989?
Ensure brevity in your answer.  1.1. What is the difference between the highest and the second highest Aid received (constant 2012 US$) in Low income?
Ensure brevity in your answer.  1.05e+09. What is the difference between the highest and the second highest Aid received (constant 2012 US$) in Gabon?
Your answer should be compact. 1.56e+07. What is the difference between the highest and the second highest Aid received (constant 2012 US$) in India?
Provide a succinct answer. 2.77e+08. What is the difference between the highest and the lowest Aid received (constant 2012 US$) in Low income?
Provide a short and direct response. 5.29e+09. What is the difference between the highest and the lowest Aid received (constant 2012 US$) in Gabon?
Make the answer very short. 8.77e+07. What is the difference between the highest and the lowest Aid received (constant 2012 US$) in India?
Ensure brevity in your answer.  1.76e+09. 